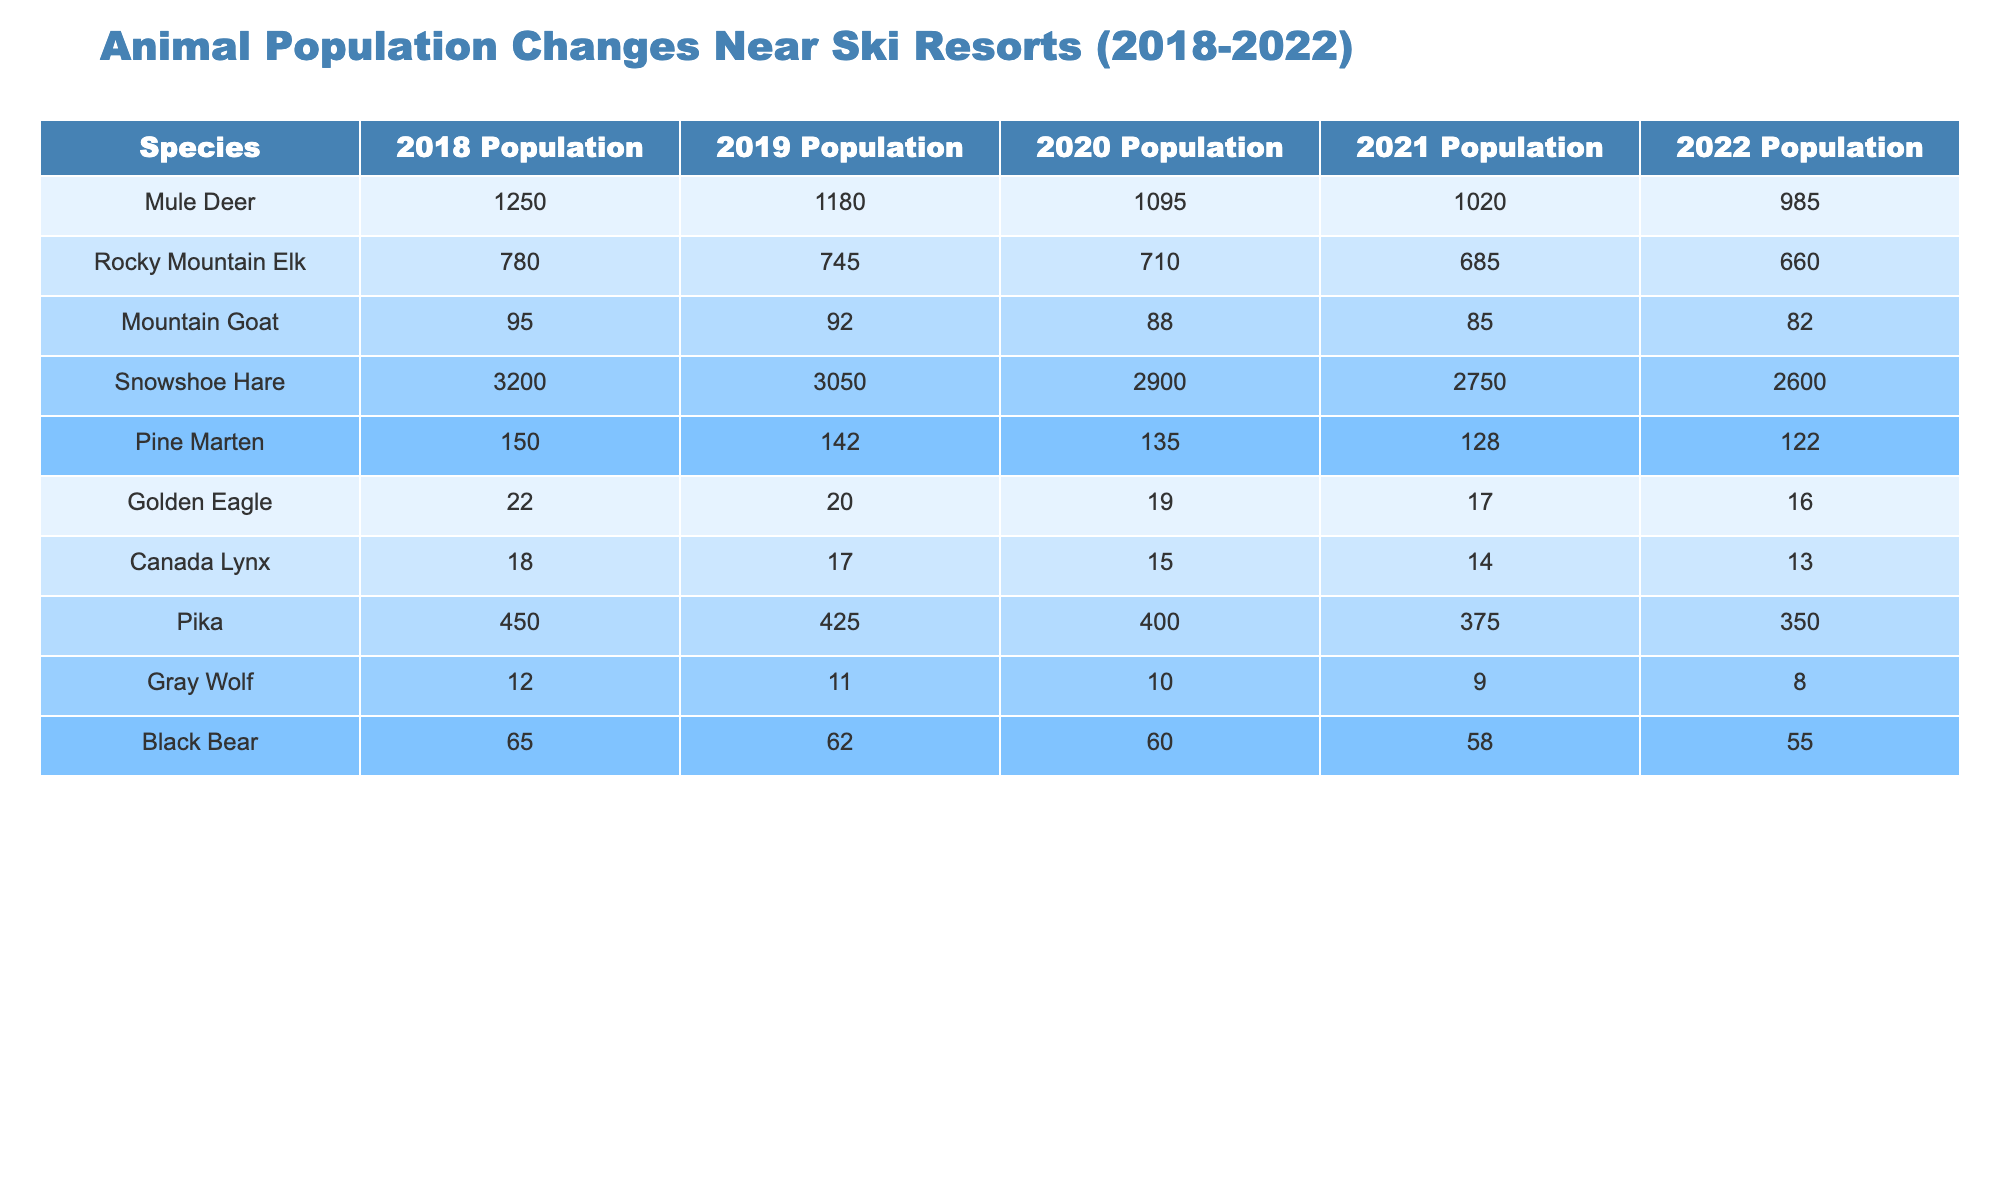What was the population of Mule Deer in 2022? The table shows that the population of Mule Deer in 2022 is listed in the corresponding column, which shows the value as 985.
Answer: 985 Which species had the highest population in 2019? By comparing the population values for each species in 2019, the Snowshoe Hare had the highest population at 3050.
Answer: Snowshoe Hare How many Rocky Mountain Elk were there in 2020 compared to 2018? The population of Rocky Mountain Elk in 2020 is 710, while in 2018 it was 780. The difference is calculated as 780 - 710 = 70.
Answer: 70 What is the average population of the Mountain Goat from 2018 to 2022? The populations for Mountain Goats from 2018 to 2022 are 95, 92, 88, 85, and 82. Adding these gives 442, and dividing by 5 (the number of years) gives an average population of 88.4, which we can round to 88.
Answer: 88 Did the population of Canada Lynx increase from 2018 to 2019? The population of Canada Lynx was 18 in 2018 and decreased to 17 in 2019. This indicates a decline, so the answer is no.
Answer: No Which species experienced the largest decline in population from 2018 to 2022? By comparing the populations for each species from 2018 to 2022, the largest decline can be calculated for the Snowshoe Hare: 3200 (2018) to 2600 (2022) represents a decline of 600. No other species had a larger drop.
Answer: Snowshoe Hare What was the overall trend in the population of Black Bears from 2018 to 2022? The populations are 65 in 2018, 62 in 2019, 60 in 2020, 58 in 2021, and 55 in 2022. Observing these values, we can see a consistent decline year over year.
Answer: Consistent decline How many species had a population below 20 in 2022? Looking at the 2022 populations, only the Golden Eagle (16) and Canada Lynx (13) had populations below 20, so there are two species.
Answer: 2 What was the total population of all species in 2021? The populations in 2021 were: Mule Deer (1020), Rocky Mountain Elk (685), Mountain Goat (85), Snowshoe Hare (2750), Pine Marten (128), Golden Eagle (17), Canada Lynx (14), Pika (375), Gray Wolf (9), and Black Bear (58). Summing these gives a total of 4660.
Answer: 4660 Which species had a population higher than 1000 in 2018? In 2018, the populations above 1000 are Mule Deer (1250) and Snowshoe Hare (3200). Thus, both species qualify.
Answer: Mule Deer and Snowshoe Hare Did the population of Pikas decrease each year from 2018 to 2022? Observing the Pika populations year by year, we have 450 in 2018, 425 in 2019, 400 in 2020, 375 in 2021, and 350 in 2022. Each year shows a reduction, confirming a continuous decline.
Answer: Yes 